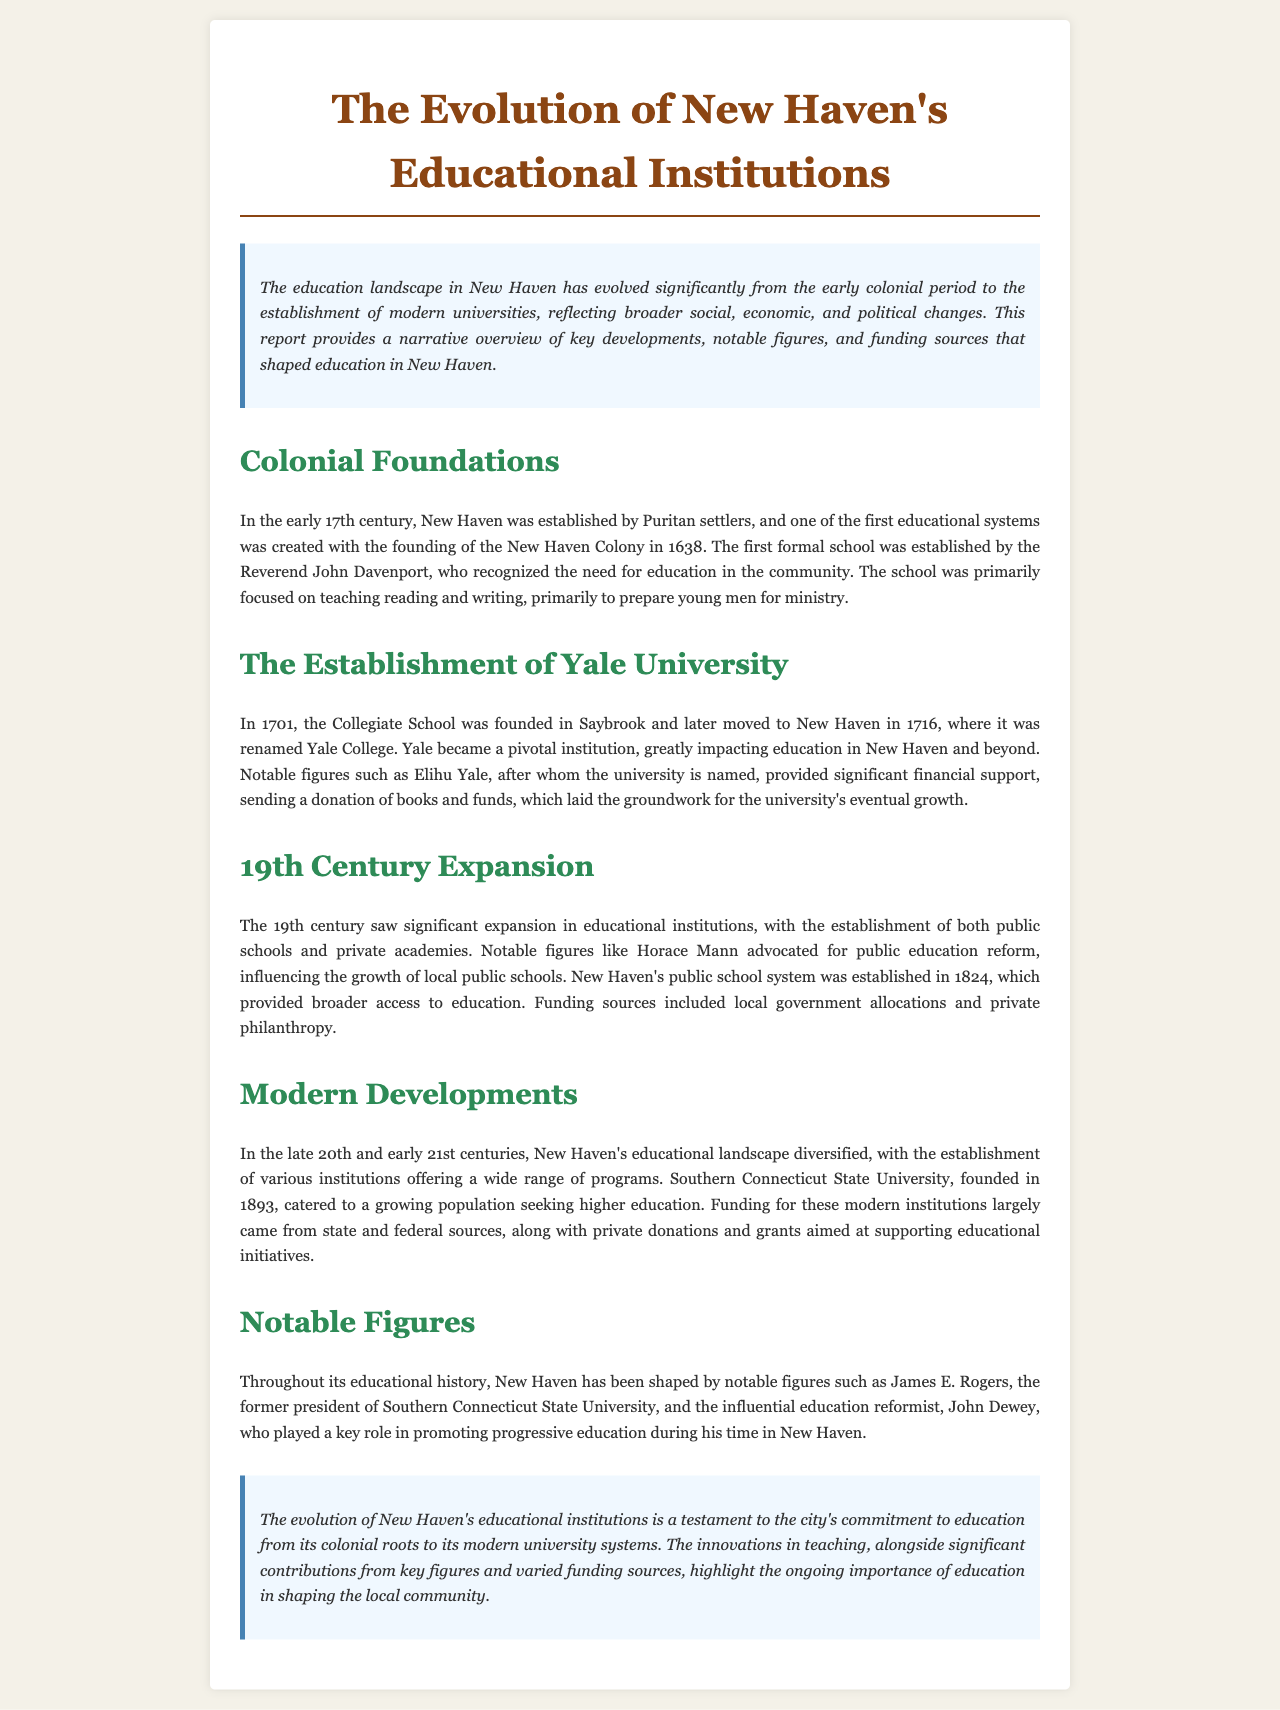What year was the New Haven Colony established? The document states that the New Haven Colony was established in 1638.
Answer: 1638 Who established the first formal school in New Haven? The document mentions that the first formal school was established by Reverend John Davenport.
Answer: Reverend John Davenport What significant institution was founded in 1701? According to the document, the Collegiate School was founded in 1701.
Answer: Collegiate School What year did New Haven's public school system get established? The document specifies that the public school system was established in 1824.
Answer: 1824 Which university was founded in 1893? The report states that Southern Connecticut State University was founded in 1893.
Answer: Southern Connecticut State University Who was influential in promoting public education reform in the 19th century? The document identifies Horace Mann as a notable figure advocating for public education reform.
Answer: Horace Mann What were the primary funding sources for modern educational institutions in New Haven? The document states that funding largely came from state and federal sources, along with private donations and grants.
Answer: State and federal sources, private donations, grants What does the introduction of the document convey about the evolution of education in New Haven? The introduction summarizes that the education landscape in New Haven has evolved significantly reflecting broader social, economic, and political changes.
Answer: Evolution of education reflecting broader changes Who was a notable education reformist mentioned in the document? The document mentions John Dewey as an influential education reformist in New Haven.
Answer: John Dewey 